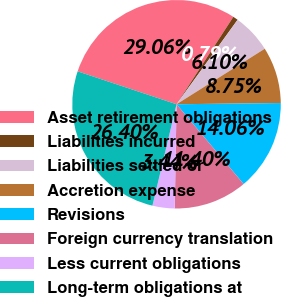<chart> <loc_0><loc_0><loc_500><loc_500><pie_chart><fcel>Asset retirement obligations<fcel>Liabilities incurred<fcel>Liabilities settled or<fcel>Accretion expense<fcel>Revisions<fcel>Foreign currency translation<fcel>Less current obligations<fcel>Long-term obligations at<nl><fcel>29.06%<fcel>0.79%<fcel>6.1%<fcel>8.75%<fcel>14.06%<fcel>11.4%<fcel>3.44%<fcel>26.4%<nl></chart> 